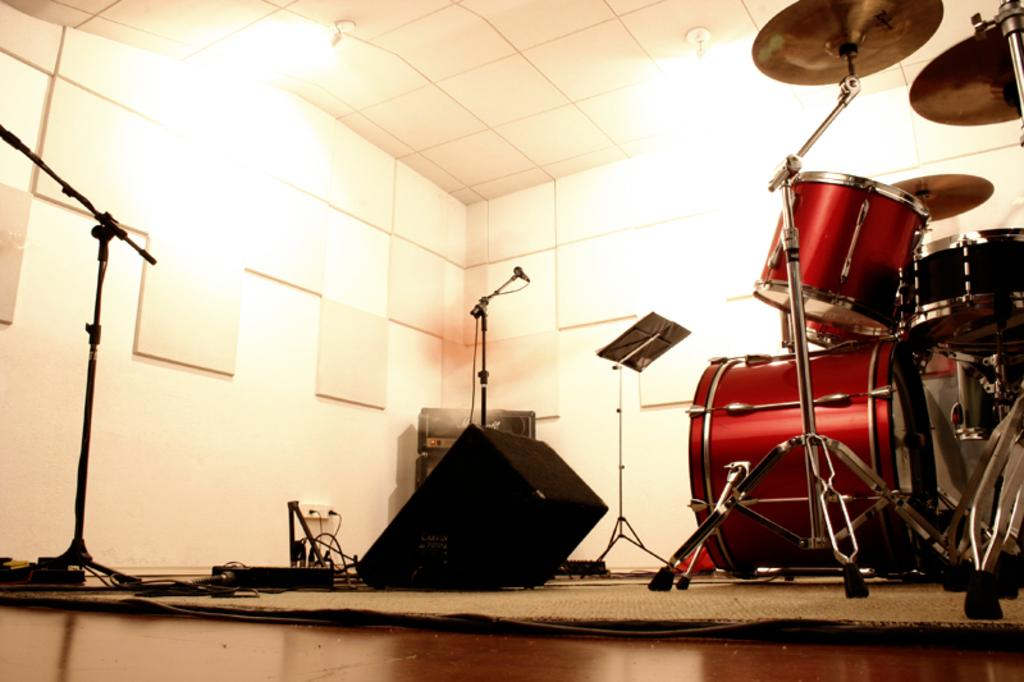What type of musical instruments are present in the image? There are drums in the image. Are there any other musical instruments besides the drums? Yes, there are other musical instruments in the image. What equipment is used for amplifying sound in the image? There are microphones in the image. What can be seen in the image that might be used for illumination? There are lights in the image. Where is the mailbox located in the image? There is no mailbox present in the image. What type of bell can be heard ringing in the image? There is no bell present in the image, and therefore no sound can be heard. 